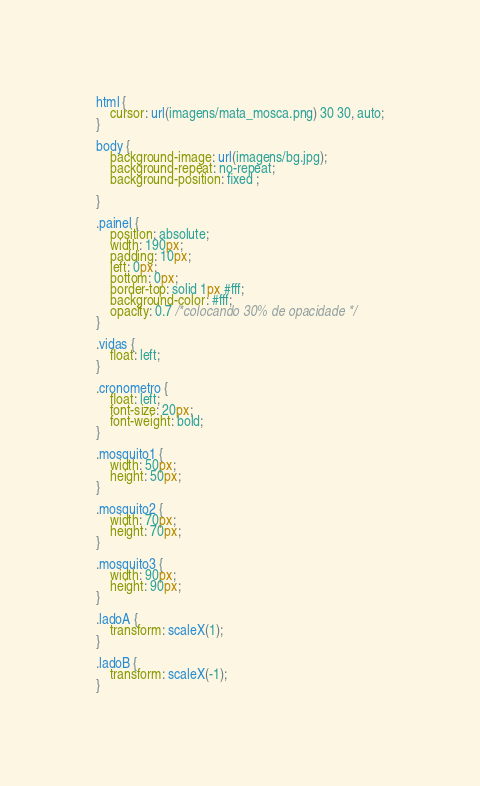<code> <loc_0><loc_0><loc_500><loc_500><_CSS_>html {
	cursor: url(imagens/mata_mosca.png) 30 30, auto;
}

body {
	background-image: url(imagens/bg.jpg);
	background-repeat: no-repeat;
	background-position: fixed ;

}

.painel {
	position: absolute;
	width: 190px;
	padding: 10px;
	left: 0px;
	bottom: 0px;
	border-top: solid 1px #fff;
	background-color: #fff;
	opacity: 0.7 /*colocando 30% de opacidade */
}

.vidas {
	float: left;
}

.cronometro {
	float: left;
	font-size: 20px;
	font-weight: bold;
}

.mosquito1 {
	width: 50px;
	height: 50px;
}

.mosquito2 {
	width: 70px;
	height: 70px;
}

.mosquito3 {
	width: 90px;
	height: 90px;
}

.ladoA {
	transform: scaleX(1);
}

.ladoB {
	transform: scaleX(-1);
}</code> 